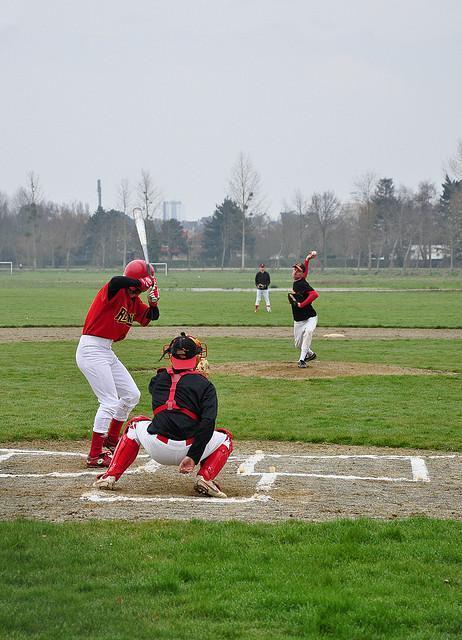How many people are there?
Give a very brief answer. 3. How many slices of pizza are present?
Give a very brief answer. 0. 